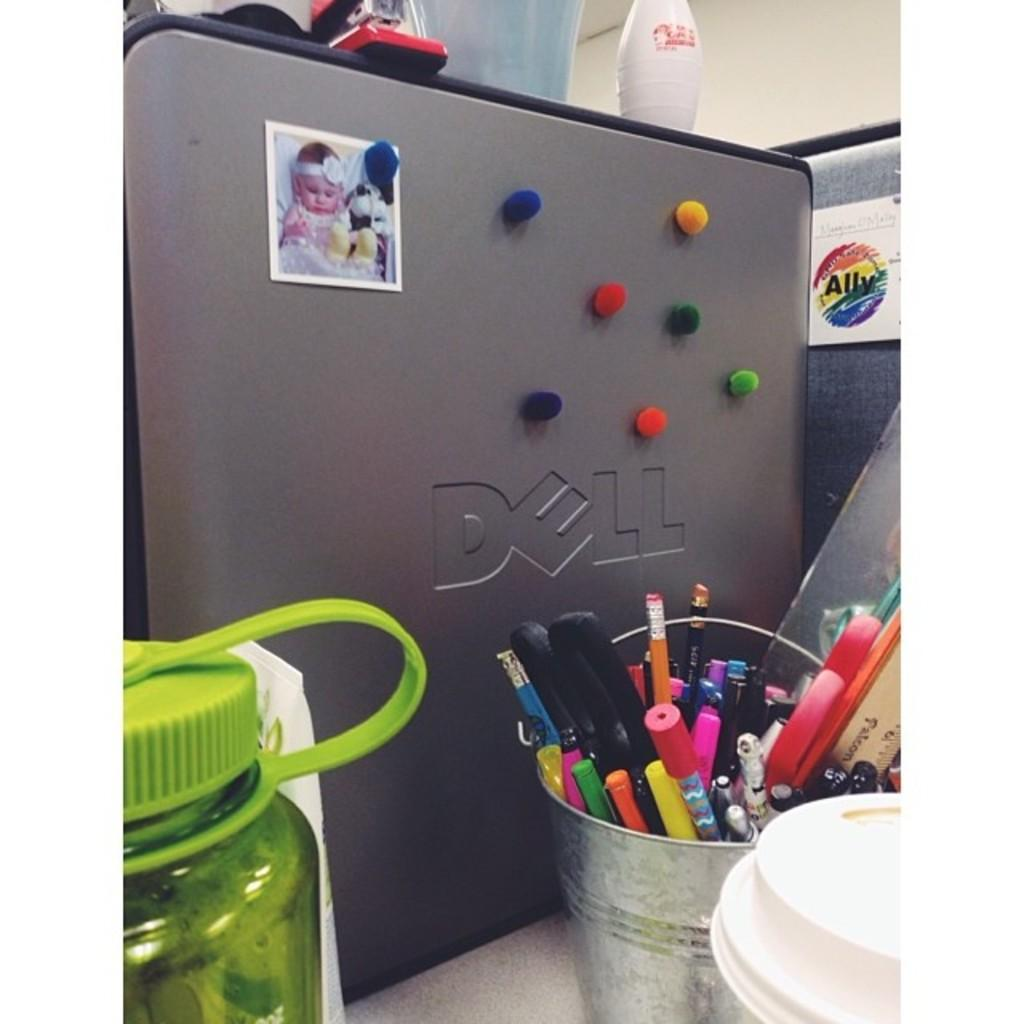<image>
Share a concise interpretation of the image provided. The Dell computer tower is decorated with colorful fuzzy balls. 